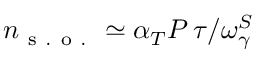Convert formula to latex. <formula><loc_0><loc_0><loc_500><loc_500>n _ { s . o . } \simeq \alpha _ { T } P \, \tau / \omega _ { \gamma } ^ { S }</formula> 